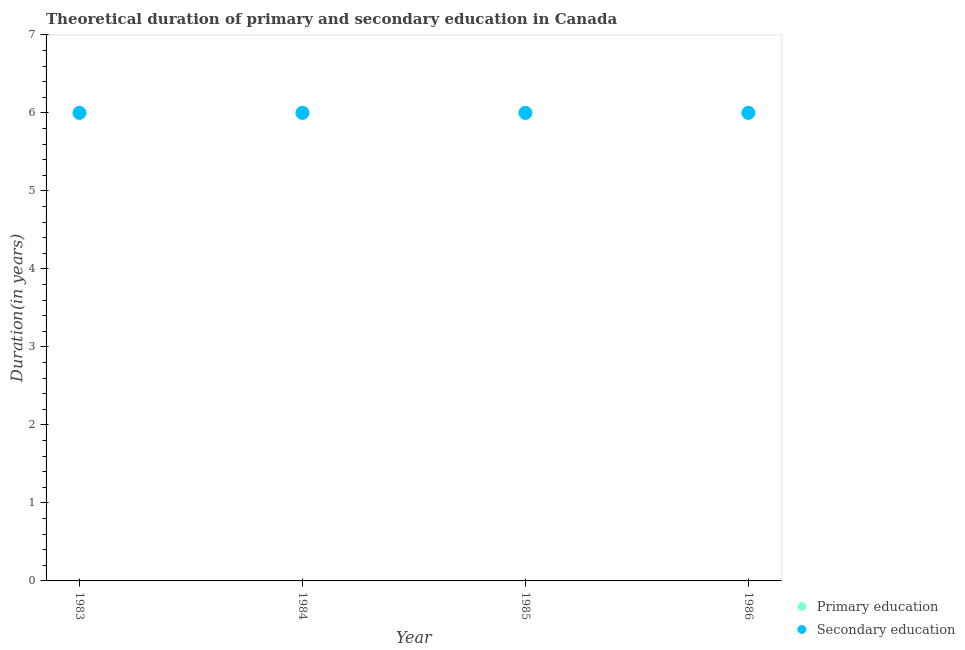How many different coloured dotlines are there?
Keep it short and to the point. 2. Is the number of dotlines equal to the number of legend labels?
Offer a very short reply. Yes. What is the duration of primary education in 1984?
Offer a very short reply. 6. What is the total duration of primary education in the graph?
Keep it short and to the point. 24. What is the difference between the duration of secondary education in 1984 and that in 1985?
Offer a terse response. 0. What is the difference between the duration of primary education in 1985 and the duration of secondary education in 1984?
Keep it short and to the point. 0. In the year 1984, what is the difference between the duration of secondary education and duration of primary education?
Offer a very short reply. 0. What is the ratio of the duration of primary education in 1984 to that in 1986?
Your answer should be compact. 1. Is the duration of secondary education in 1983 less than that in 1986?
Give a very brief answer. No. What is the difference between the highest and the second highest duration of secondary education?
Make the answer very short. 0. What is the difference between the highest and the lowest duration of secondary education?
Offer a very short reply. 0. Is the duration of primary education strictly greater than the duration of secondary education over the years?
Offer a terse response. No. Is the duration of secondary education strictly less than the duration of primary education over the years?
Offer a terse response. No. What is the difference between two consecutive major ticks on the Y-axis?
Ensure brevity in your answer.  1. Does the graph contain any zero values?
Provide a short and direct response. No. Does the graph contain grids?
Provide a short and direct response. No. Where does the legend appear in the graph?
Your answer should be compact. Bottom right. How many legend labels are there?
Provide a short and direct response. 2. What is the title of the graph?
Your answer should be compact. Theoretical duration of primary and secondary education in Canada. Does "Urban" appear as one of the legend labels in the graph?
Your response must be concise. No. What is the label or title of the Y-axis?
Keep it short and to the point. Duration(in years). What is the Duration(in years) of Primary education in 1983?
Your answer should be very brief. 6. What is the Duration(in years) in Secondary education in 1983?
Offer a very short reply. 6. What is the Duration(in years) in Primary education in 1984?
Your response must be concise. 6. What is the Duration(in years) in Primary education in 1986?
Give a very brief answer. 6. Across all years, what is the maximum Duration(in years) of Primary education?
Your answer should be very brief. 6. Across all years, what is the maximum Duration(in years) in Secondary education?
Ensure brevity in your answer.  6. What is the total Duration(in years) in Primary education in the graph?
Your response must be concise. 24. What is the total Duration(in years) of Secondary education in the graph?
Offer a terse response. 24. What is the difference between the Duration(in years) in Primary education in 1983 and that in 1986?
Provide a short and direct response. 0. What is the difference between the Duration(in years) of Primary education in 1984 and that in 1985?
Offer a terse response. 0. What is the difference between the Duration(in years) of Secondary education in 1984 and that in 1985?
Make the answer very short. 0. What is the difference between the Duration(in years) in Primary education in 1984 and that in 1986?
Your answer should be compact. 0. What is the difference between the Duration(in years) of Secondary education in 1984 and that in 1986?
Provide a succinct answer. 0. What is the difference between the Duration(in years) in Primary education in 1985 and that in 1986?
Ensure brevity in your answer.  0. What is the difference between the Duration(in years) of Secondary education in 1985 and that in 1986?
Provide a short and direct response. 0. What is the difference between the Duration(in years) of Primary education in 1983 and the Duration(in years) of Secondary education in 1984?
Your response must be concise. 0. What is the difference between the Duration(in years) of Primary education in 1983 and the Duration(in years) of Secondary education in 1985?
Provide a succinct answer. 0. What is the difference between the Duration(in years) in Primary education in 1984 and the Duration(in years) in Secondary education in 1985?
Ensure brevity in your answer.  0. What is the difference between the Duration(in years) in Primary education in 1984 and the Duration(in years) in Secondary education in 1986?
Provide a succinct answer. 0. What is the difference between the Duration(in years) of Primary education in 1985 and the Duration(in years) of Secondary education in 1986?
Give a very brief answer. 0. What is the average Duration(in years) in Primary education per year?
Offer a very short reply. 6. In the year 1984, what is the difference between the Duration(in years) of Primary education and Duration(in years) of Secondary education?
Make the answer very short. 0. In the year 1986, what is the difference between the Duration(in years) of Primary education and Duration(in years) of Secondary education?
Keep it short and to the point. 0. What is the ratio of the Duration(in years) in Secondary education in 1983 to that in 1984?
Offer a terse response. 1. What is the ratio of the Duration(in years) in Secondary education in 1983 to that in 1985?
Your response must be concise. 1. What is the ratio of the Duration(in years) in Primary education in 1983 to that in 1986?
Provide a short and direct response. 1. What is the ratio of the Duration(in years) of Secondary education in 1983 to that in 1986?
Your answer should be compact. 1. What is the ratio of the Duration(in years) of Secondary education in 1984 to that in 1985?
Ensure brevity in your answer.  1. What is the ratio of the Duration(in years) of Secondary education in 1984 to that in 1986?
Give a very brief answer. 1. What is the difference between the highest and the second highest Duration(in years) of Secondary education?
Offer a terse response. 0. What is the difference between the highest and the lowest Duration(in years) in Primary education?
Give a very brief answer. 0. What is the difference between the highest and the lowest Duration(in years) of Secondary education?
Offer a very short reply. 0. 